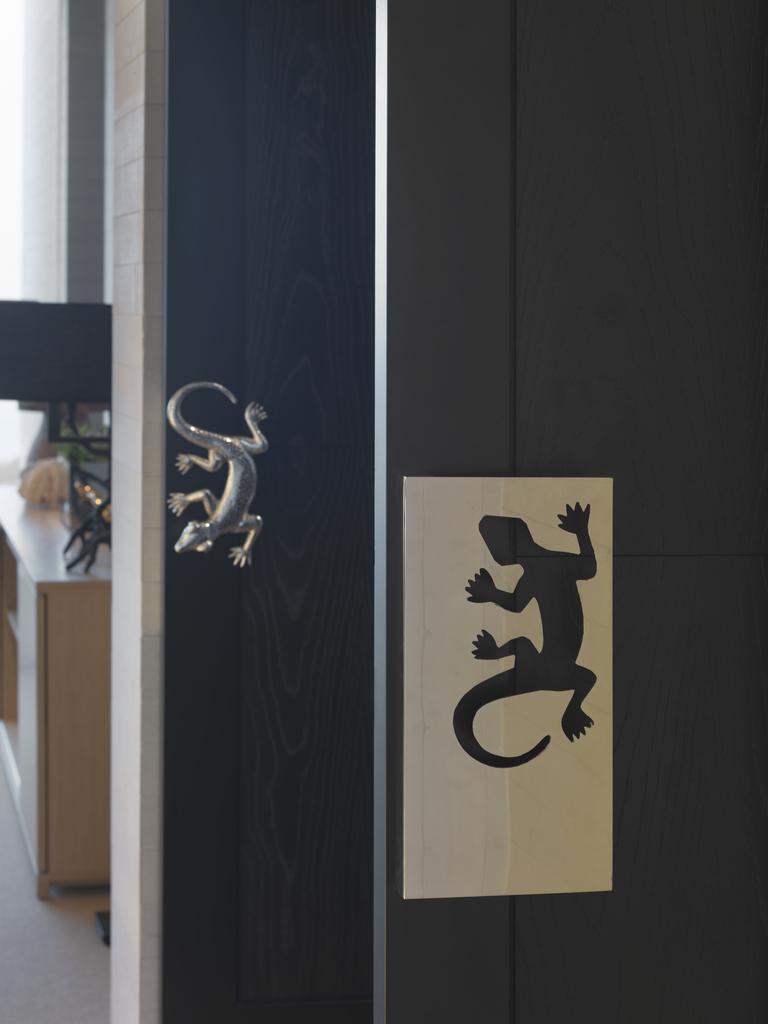In one or two sentences, can you explain what this image depicts? In the image there is lizard sticker on the wall and beside it there is a metal lizard idol on the wall, on the left side there is a table with some things above it. 